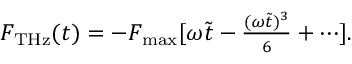<formula> <loc_0><loc_0><loc_500><loc_500>\begin{array} { r } { F _ { T H z } ( t ) = - F _ { \max } [ \omega \tilde { t } - \frac { ( \omega \tilde { t } ) ^ { 3 } } { 6 } + \cdots ] . } \end{array}</formula> 